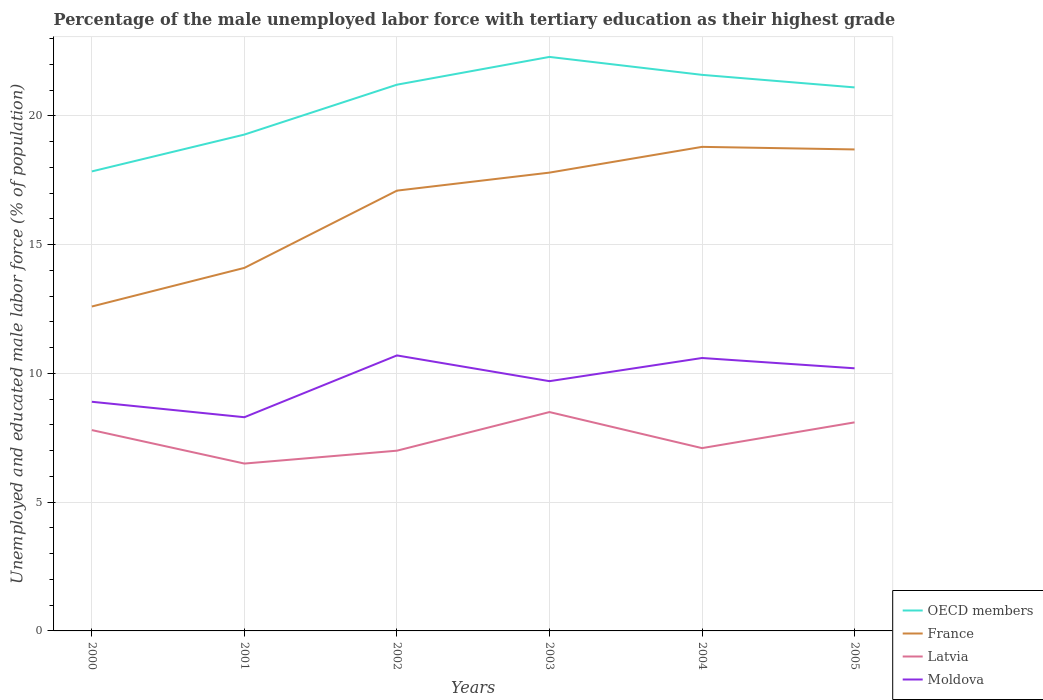How many different coloured lines are there?
Offer a terse response. 4. Does the line corresponding to France intersect with the line corresponding to Moldova?
Provide a succinct answer. No. Across all years, what is the maximum percentage of the unemployed male labor force with tertiary education in France?
Your answer should be very brief. 12.6. In which year was the percentage of the unemployed male labor force with tertiary education in France maximum?
Offer a very short reply. 2000. What is the total percentage of the unemployed male labor force with tertiary education in Moldova in the graph?
Provide a short and direct response. 0.4. What is the difference between the highest and the second highest percentage of the unemployed male labor force with tertiary education in Moldova?
Make the answer very short. 2.4. Is the percentage of the unemployed male labor force with tertiary education in Latvia strictly greater than the percentage of the unemployed male labor force with tertiary education in OECD members over the years?
Ensure brevity in your answer.  Yes. How many years are there in the graph?
Ensure brevity in your answer.  6. What is the difference between two consecutive major ticks on the Y-axis?
Your answer should be compact. 5. Does the graph contain grids?
Make the answer very short. Yes. What is the title of the graph?
Keep it short and to the point. Percentage of the male unemployed labor force with tertiary education as their highest grade. What is the label or title of the X-axis?
Your response must be concise. Years. What is the label or title of the Y-axis?
Your response must be concise. Unemployed and educated male labor force (% of population). What is the Unemployed and educated male labor force (% of population) of OECD members in 2000?
Offer a very short reply. 17.85. What is the Unemployed and educated male labor force (% of population) in France in 2000?
Give a very brief answer. 12.6. What is the Unemployed and educated male labor force (% of population) of Latvia in 2000?
Provide a succinct answer. 7.8. What is the Unemployed and educated male labor force (% of population) of Moldova in 2000?
Ensure brevity in your answer.  8.9. What is the Unemployed and educated male labor force (% of population) of OECD members in 2001?
Provide a short and direct response. 19.28. What is the Unemployed and educated male labor force (% of population) of France in 2001?
Give a very brief answer. 14.1. What is the Unemployed and educated male labor force (% of population) in Latvia in 2001?
Offer a very short reply. 6.5. What is the Unemployed and educated male labor force (% of population) of Moldova in 2001?
Your answer should be very brief. 8.3. What is the Unemployed and educated male labor force (% of population) in OECD members in 2002?
Offer a very short reply. 21.21. What is the Unemployed and educated male labor force (% of population) in France in 2002?
Your response must be concise. 17.1. What is the Unemployed and educated male labor force (% of population) of Moldova in 2002?
Give a very brief answer. 10.7. What is the Unemployed and educated male labor force (% of population) in OECD members in 2003?
Your answer should be compact. 22.29. What is the Unemployed and educated male labor force (% of population) in France in 2003?
Provide a succinct answer. 17.8. What is the Unemployed and educated male labor force (% of population) of Moldova in 2003?
Give a very brief answer. 9.7. What is the Unemployed and educated male labor force (% of population) of OECD members in 2004?
Provide a succinct answer. 21.6. What is the Unemployed and educated male labor force (% of population) in France in 2004?
Ensure brevity in your answer.  18.8. What is the Unemployed and educated male labor force (% of population) of Latvia in 2004?
Give a very brief answer. 7.1. What is the Unemployed and educated male labor force (% of population) of Moldova in 2004?
Offer a terse response. 10.6. What is the Unemployed and educated male labor force (% of population) of OECD members in 2005?
Ensure brevity in your answer.  21.11. What is the Unemployed and educated male labor force (% of population) in France in 2005?
Provide a succinct answer. 18.7. What is the Unemployed and educated male labor force (% of population) of Latvia in 2005?
Keep it short and to the point. 8.1. What is the Unemployed and educated male labor force (% of population) in Moldova in 2005?
Your answer should be compact. 10.2. Across all years, what is the maximum Unemployed and educated male labor force (% of population) in OECD members?
Keep it short and to the point. 22.29. Across all years, what is the maximum Unemployed and educated male labor force (% of population) in France?
Provide a succinct answer. 18.8. Across all years, what is the maximum Unemployed and educated male labor force (% of population) in Latvia?
Provide a short and direct response. 8.5. Across all years, what is the maximum Unemployed and educated male labor force (% of population) of Moldova?
Your answer should be very brief. 10.7. Across all years, what is the minimum Unemployed and educated male labor force (% of population) in OECD members?
Offer a terse response. 17.85. Across all years, what is the minimum Unemployed and educated male labor force (% of population) of France?
Provide a succinct answer. 12.6. Across all years, what is the minimum Unemployed and educated male labor force (% of population) of Moldova?
Provide a short and direct response. 8.3. What is the total Unemployed and educated male labor force (% of population) of OECD members in the graph?
Provide a short and direct response. 123.34. What is the total Unemployed and educated male labor force (% of population) in France in the graph?
Your answer should be very brief. 99.1. What is the total Unemployed and educated male labor force (% of population) in Moldova in the graph?
Your answer should be very brief. 58.4. What is the difference between the Unemployed and educated male labor force (% of population) in OECD members in 2000 and that in 2001?
Offer a very short reply. -1.43. What is the difference between the Unemployed and educated male labor force (% of population) of OECD members in 2000 and that in 2002?
Your answer should be compact. -3.37. What is the difference between the Unemployed and educated male labor force (% of population) in Latvia in 2000 and that in 2002?
Your answer should be very brief. 0.8. What is the difference between the Unemployed and educated male labor force (% of population) of OECD members in 2000 and that in 2003?
Give a very brief answer. -4.45. What is the difference between the Unemployed and educated male labor force (% of population) of France in 2000 and that in 2003?
Offer a very short reply. -5.2. What is the difference between the Unemployed and educated male labor force (% of population) in Latvia in 2000 and that in 2003?
Keep it short and to the point. -0.7. What is the difference between the Unemployed and educated male labor force (% of population) in Moldova in 2000 and that in 2003?
Your answer should be compact. -0.8. What is the difference between the Unemployed and educated male labor force (% of population) of OECD members in 2000 and that in 2004?
Provide a succinct answer. -3.75. What is the difference between the Unemployed and educated male labor force (% of population) in France in 2000 and that in 2004?
Provide a succinct answer. -6.2. What is the difference between the Unemployed and educated male labor force (% of population) in Latvia in 2000 and that in 2004?
Your answer should be very brief. 0.7. What is the difference between the Unemployed and educated male labor force (% of population) of Moldova in 2000 and that in 2004?
Offer a terse response. -1.7. What is the difference between the Unemployed and educated male labor force (% of population) in OECD members in 2000 and that in 2005?
Offer a very short reply. -3.26. What is the difference between the Unemployed and educated male labor force (% of population) of France in 2000 and that in 2005?
Provide a succinct answer. -6.1. What is the difference between the Unemployed and educated male labor force (% of population) of OECD members in 2001 and that in 2002?
Ensure brevity in your answer.  -1.94. What is the difference between the Unemployed and educated male labor force (% of population) in France in 2001 and that in 2002?
Give a very brief answer. -3. What is the difference between the Unemployed and educated male labor force (% of population) in Moldova in 2001 and that in 2002?
Give a very brief answer. -2.4. What is the difference between the Unemployed and educated male labor force (% of population) of OECD members in 2001 and that in 2003?
Offer a very short reply. -3.02. What is the difference between the Unemployed and educated male labor force (% of population) in France in 2001 and that in 2003?
Provide a short and direct response. -3.7. What is the difference between the Unemployed and educated male labor force (% of population) of Latvia in 2001 and that in 2003?
Offer a very short reply. -2. What is the difference between the Unemployed and educated male labor force (% of population) of OECD members in 2001 and that in 2004?
Your response must be concise. -2.32. What is the difference between the Unemployed and educated male labor force (% of population) in OECD members in 2001 and that in 2005?
Provide a succinct answer. -1.83. What is the difference between the Unemployed and educated male labor force (% of population) in OECD members in 2002 and that in 2003?
Provide a short and direct response. -1.08. What is the difference between the Unemployed and educated male labor force (% of population) of France in 2002 and that in 2003?
Give a very brief answer. -0.7. What is the difference between the Unemployed and educated male labor force (% of population) in Latvia in 2002 and that in 2003?
Your answer should be compact. -1.5. What is the difference between the Unemployed and educated male labor force (% of population) in OECD members in 2002 and that in 2004?
Keep it short and to the point. -0.38. What is the difference between the Unemployed and educated male labor force (% of population) of France in 2002 and that in 2004?
Make the answer very short. -1.7. What is the difference between the Unemployed and educated male labor force (% of population) in Latvia in 2002 and that in 2004?
Offer a very short reply. -0.1. What is the difference between the Unemployed and educated male labor force (% of population) of Moldova in 2002 and that in 2004?
Offer a terse response. 0.1. What is the difference between the Unemployed and educated male labor force (% of population) in OECD members in 2002 and that in 2005?
Offer a very short reply. 0.11. What is the difference between the Unemployed and educated male labor force (% of population) in France in 2002 and that in 2005?
Give a very brief answer. -1.6. What is the difference between the Unemployed and educated male labor force (% of population) of Latvia in 2002 and that in 2005?
Offer a terse response. -1.1. What is the difference between the Unemployed and educated male labor force (% of population) of OECD members in 2003 and that in 2004?
Keep it short and to the point. 0.7. What is the difference between the Unemployed and educated male labor force (% of population) of Moldova in 2003 and that in 2004?
Your answer should be very brief. -0.9. What is the difference between the Unemployed and educated male labor force (% of population) of OECD members in 2003 and that in 2005?
Your answer should be compact. 1.18. What is the difference between the Unemployed and educated male labor force (% of population) in France in 2003 and that in 2005?
Your response must be concise. -0.9. What is the difference between the Unemployed and educated male labor force (% of population) in Latvia in 2003 and that in 2005?
Give a very brief answer. 0.4. What is the difference between the Unemployed and educated male labor force (% of population) in OECD members in 2004 and that in 2005?
Offer a terse response. 0.49. What is the difference between the Unemployed and educated male labor force (% of population) of France in 2004 and that in 2005?
Offer a very short reply. 0.1. What is the difference between the Unemployed and educated male labor force (% of population) in Latvia in 2004 and that in 2005?
Keep it short and to the point. -1. What is the difference between the Unemployed and educated male labor force (% of population) in Moldova in 2004 and that in 2005?
Provide a succinct answer. 0.4. What is the difference between the Unemployed and educated male labor force (% of population) of OECD members in 2000 and the Unemployed and educated male labor force (% of population) of France in 2001?
Your response must be concise. 3.75. What is the difference between the Unemployed and educated male labor force (% of population) of OECD members in 2000 and the Unemployed and educated male labor force (% of population) of Latvia in 2001?
Provide a succinct answer. 11.35. What is the difference between the Unemployed and educated male labor force (% of population) in OECD members in 2000 and the Unemployed and educated male labor force (% of population) in Moldova in 2001?
Provide a succinct answer. 9.55. What is the difference between the Unemployed and educated male labor force (% of population) in France in 2000 and the Unemployed and educated male labor force (% of population) in Latvia in 2001?
Offer a terse response. 6.1. What is the difference between the Unemployed and educated male labor force (% of population) of France in 2000 and the Unemployed and educated male labor force (% of population) of Moldova in 2001?
Provide a succinct answer. 4.3. What is the difference between the Unemployed and educated male labor force (% of population) of OECD members in 2000 and the Unemployed and educated male labor force (% of population) of France in 2002?
Your response must be concise. 0.75. What is the difference between the Unemployed and educated male labor force (% of population) of OECD members in 2000 and the Unemployed and educated male labor force (% of population) of Latvia in 2002?
Your response must be concise. 10.85. What is the difference between the Unemployed and educated male labor force (% of population) in OECD members in 2000 and the Unemployed and educated male labor force (% of population) in Moldova in 2002?
Offer a terse response. 7.15. What is the difference between the Unemployed and educated male labor force (% of population) in OECD members in 2000 and the Unemployed and educated male labor force (% of population) in France in 2003?
Give a very brief answer. 0.05. What is the difference between the Unemployed and educated male labor force (% of population) of OECD members in 2000 and the Unemployed and educated male labor force (% of population) of Latvia in 2003?
Make the answer very short. 9.35. What is the difference between the Unemployed and educated male labor force (% of population) of OECD members in 2000 and the Unemployed and educated male labor force (% of population) of Moldova in 2003?
Your answer should be very brief. 8.15. What is the difference between the Unemployed and educated male labor force (% of population) in France in 2000 and the Unemployed and educated male labor force (% of population) in Latvia in 2003?
Give a very brief answer. 4.1. What is the difference between the Unemployed and educated male labor force (% of population) of OECD members in 2000 and the Unemployed and educated male labor force (% of population) of France in 2004?
Your answer should be very brief. -0.95. What is the difference between the Unemployed and educated male labor force (% of population) of OECD members in 2000 and the Unemployed and educated male labor force (% of population) of Latvia in 2004?
Offer a terse response. 10.75. What is the difference between the Unemployed and educated male labor force (% of population) of OECD members in 2000 and the Unemployed and educated male labor force (% of population) of Moldova in 2004?
Your answer should be very brief. 7.25. What is the difference between the Unemployed and educated male labor force (% of population) in France in 2000 and the Unemployed and educated male labor force (% of population) in Moldova in 2004?
Provide a short and direct response. 2. What is the difference between the Unemployed and educated male labor force (% of population) of Latvia in 2000 and the Unemployed and educated male labor force (% of population) of Moldova in 2004?
Provide a short and direct response. -2.8. What is the difference between the Unemployed and educated male labor force (% of population) of OECD members in 2000 and the Unemployed and educated male labor force (% of population) of France in 2005?
Offer a very short reply. -0.85. What is the difference between the Unemployed and educated male labor force (% of population) in OECD members in 2000 and the Unemployed and educated male labor force (% of population) in Latvia in 2005?
Your answer should be compact. 9.75. What is the difference between the Unemployed and educated male labor force (% of population) of OECD members in 2000 and the Unemployed and educated male labor force (% of population) of Moldova in 2005?
Your answer should be compact. 7.65. What is the difference between the Unemployed and educated male labor force (% of population) in France in 2000 and the Unemployed and educated male labor force (% of population) in Latvia in 2005?
Your answer should be very brief. 4.5. What is the difference between the Unemployed and educated male labor force (% of population) in France in 2000 and the Unemployed and educated male labor force (% of population) in Moldova in 2005?
Keep it short and to the point. 2.4. What is the difference between the Unemployed and educated male labor force (% of population) of Latvia in 2000 and the Unemployed and educated male labor force (% of population) of Moldova in 2005?
Offer a terse response. -2.4. What is the difference between the Unemployed and educated male labor force (% of population) in OECD members in 2001 and the Unemployed and educated male labor force (% of population) in France in 2002?
Your response must be concise. 2.18. What is the difference between the Unemployed and educated male labor force (% of population) of OECD members in 2001 and the Unemployed and educated male labor force (% of population) of Latvia in 2002?
Provide a succinct answer. 12.28. What is the difference between the Unemployed and educated male labor force (% of population) in OECD members in 2001 and the Unemployed and educated male labor force (% of population) in Moldova in 2002?
Ensure brevity in your answer.  8.58. What is the difference between the Unemployed and educated male labor force (% of population) of France in 2001 and the Unemployed and educated male labor force (% of population) of Latvia in 2002?
Your answer should be very brief. 7.1. What is the difference between the Unemployed and educated male labor force (% of population) of France in 2001 and the Unemployed and educated male labor force (% of population) of Moldova in 2002?
Make the answer very short. 3.4. What is the difference between the Unemployed and educated male labor force (% of population) in OECD members in 2001 and the Unemployed and educated male labor force (% of population) in France in 2003?
Offer a very short reply. 1.48. What is the difference between the Unemployed and educated male labor force (% of population) in OECD members in 2001 and the Unemployed and educated male labor force (% of population) in Latvia in 2003?
Offer a very short reply. 10.78. What is the difference between the Unemployed and educated male labor force (% of population) of OECD members in 2001 and the Unemployed and educated male labor force (% of population) of Moldova in 2003?
Give a very brief answer. 9.58. What is the difference between the Unemployed and educated male labor force (% of population) of OECD members in 2001 and the Unemployed and educated male labor force (% of population) of France in 2004?
Keep it short and to the point. 0.48. What is the difference between the Unemployed and educated male labor force (% of population) of OECD members in 2001 and the Unemployed and educated male labor force (% of population) of Latvia in 2004?
Give a very brief answer. 12.18. What is the difference between the Unemployed and educated male labor force (% of population) of OECD members in 2001 and the Unemployed and educated male labor force (% of population) of Moldova in 2004?
Provide a short and direct response. 8.68. What is the difference between the Unemployed and educated male labor force (% of population) in France in 2001 and the Unemployed and educated male labor force (% of population) in Latvia in 2004?
Your answer should be very brief. 7. What is the difference between the Unemployed and educated male labor force (% of population) of France in 2001 and the Unemployed and educated male labor force (% of population) of Moldova in 2004?
Your response must be concise. 3.5. What is the difference between the Unemployed and educated male labor force (% of population) in OECD members in 2001 and the Unemployed and educated male labor force (% of population) in France in 2005?
Provide a short and direct response. 0.58. What is the difference between the Unemployed and educated male labor force (% of population) of OECD members in 2001 and the Unemployed and educated male labor force (% of population) of Latvia in 2005?
Your answer should be very brief. 11.18. What is the difference between the Unemployed and educated male labor force (% of population) of OECD members in 2001 and the Unemployed and educated male labor force (% of population) of Moldova in 2005?
Keep it short and to the point. 9.08. What is the difference between the Unemployed and educated male labor force (% of population) of France in 2001 and the Unemployed and educated male labor force (% of population) of Latvia in 2005?
Provide a succinct answer. 6. What is the difference between the Unemployed and educated male labor force (% of population) of OECD members in 2002 and the Unemployed and educated male labor force (% of population) of France in 2003?
Keep it short and to the point. 3.41. What is the difference between the Unemployed and educated male labor force (% of population) of OECD members in 2002 and the Unemployed and educated male labor force (% of population) of Latvia in 2003?
Offer a terse response. 12.71. What is the difference between the Unemployed and educated male labor force (% of population) of OECD members in 2002 and the Unemployed and educated male labor force (% of population) of Moldova in 2003?
Your answer should be very brief. 11.51. What is the difference between the Unemployed and educated male labor force (% of population) of OECD members in 2002 and the Unemployed and educated male labor force (% of population) of France in 2004?
Provide a succinct answer. 2.41. What is the difference between the Unemployed and educated male labor force (% of population) in OECD members in 2002 and the Unemployed and educated male labor force (% of population) in Latvia in 2004?
Provide a succinct answer. 14.11. What is the difference between the Unemployed and educated male labor force (% of population) in OECD members in 2002 and the Unemployed and educated male labor force (% of population) in Moldova in 2004?
Your answer should be compact. 10.61. What is the difference between the Unemployed and educated male labor force (% of population) in France in 2002 and the Unemployed and educated male labor force (% of population) in Moldova in 2004?
Offer a very short reply. 6.5. What is the difference between the Unemployed and educated male labor force (% of population) of OECD members in 2002 and the Unemployed and educated male labor force (% of population) of France in 2005?
Offer a terse response. 2.51. What is the difference between the Unemployed and educated male labor force (% of population) of OECD members in 2002 and the Unemployed and educated male labor force (% of population) of Latvia in 2005?
Make the answer very short. 13.11. What is the difference between the Unemployed and educated male labor force (% of population) of OECD members in 2002 and the Unemployed and educated male labor force (% of population) of Moldova in 2005?
Provide a succinct answer. 11.01. What is the difference between the Unemployed and educated male labor force (% of population) of France in 2002 and the Unemployed and educated male labor force (% of population) of Latvia in 2005?
Keep it short and to the point. 9. What is the difference between the Unemployed and educated male labor force (% of population) of OECD members in 2003 and the Unemployed and educated male labor force (% of population) of France in 2004?
Offer a terse response. 3.49. What is the difference between the Unemployed and educated male labor force (% of population) of OECD members in 2003 and the Unemployed and educated male labor force (% of population) of Latvia in 2004?
Give a very brief answer. 15.19. What is the difference between the Unemployed and educated male labor force (% of population) in OECD members in 2003 and the Unemployed and educated male labor force (% of population) in Moldova in 2004?
Offer a very short reply. 11.69. What is the difference between the Unemployed and educated male labor force (% of population) in OECD members in 2003 and the Unemployed and educated male labor force (% of population) in France in 2005?
Provide a short and direct response. 3.59. What is the difference between the Unemployed and educated male labor force (% of population) of OECD members in 2003 and the Unemployed and educated male labor force (% of population) of Latvia in 2005?
Your answer should be compact. 14.19. What is the difference between the Unemployed and educated male labor force (% of population) of OECD members in 2003 and the Unemployed and educated male labor force (% of population) of Moldova in 2005?
Your response must be concise. 12.09. What is the difference between the Unemployed and educated male labor force (% of population) in France in 2003 and the Unemployed and educated male labor force (% of population) in Moldova in 2005?
Your answer should be very brief. 7.6. What is the difference between the Unemployed and educated male labor force (% of population) of OECD members in 2004 and the Unemployed and educated male labor force (% of population) of France in 2005?
Your response must be concise. 2.9. What is the difference between the Unemployed and educated male labor force (% of population) of OECD members in 2004 and the Unemployed and educated male labor force (% of population) of Latvia in 2005?
Your answer should be compact. 13.5. What is the difference between the Unemployed and educated male labor force (% of population) in OECD members in 2004 and the Unemployed and educated male labor force (% of population) in Moldova in 2005?
Give a very brief answer. 11.4. What is the difference between the Unemployed and educated male labor force (% of population) in Latvia in 2004 and the Unemployed and educated male labor force (% of population) in Moldova in 2005?
Ensure brevity in your answer.  -3.1. What is the average Unemployed and educated male labor force (% of population) of OECD members per year?
Offer a terse response. 20.56. What is the average Unemployed and educated male labor force (% of population) in France per year?
Your response must be concise. 16.52. What is the average Unemployed and educated male labor force (% of population) of Moldova per year?
Offer a very short reply. 9.73. In the year 2000, what is the difference between the Unemployed and educated male labor force (% of population) of OECD members and Unemployed and educated male labor force (% of population) of France?
Ensure brevity in your answer.  5.25. In the year 2000, what is the difference between the Unemployed and educated male labor force (% of population) in OECD members and Unemployed and educated male labor force (% of population) in Latvia?
Keep it short and to the point. 10.05. In the year 2000, what is the difference between the Unemployed and educated male labor force (% of population) of OECD members and Unemployed and educated male labor force (% of population) of Moldova?
Your answer should be compact. 8.95. In the year 2000, what is the difference between the Unemployed and educated male labor force (% of population) in France and Unemployed and educated male labor force (% of population) in Latvia?
Your answer should be very brief. 4.8. In the year 2000, what is the difference between the Unemployed and educated male labor force (% of population) of Latvia and Unemployed and educated male labor force (% of population) of Moldova?
Offer a terse response. -1.1. In the year 2001, what is the difference between the Unemployed and educated male labor force (% of population) of OECD members and Unemployed and educated male labor force (% of population) of France?
Ensure brevity in your answer.  5.18. In the year 2001, what is the difference between the Unemployed and educated male labor force (% of population) in OECD members and Unemployed and educated male labor force (% of population) in Latvia?
Your answer should be compact. 12.78. In the year 2001, what is the difference between the Unemployed and educated male labor force (% of population) of OECD members and Unemployed and educated male labor force (% of population) of Moldova?
Ensure brevity in your answer.  10.98. In the year 2001, what is the difference between the Unemployed and educated male labor force (% of population) in France and Unemployed and educated male labor force (% of population) in Latvia?
Provide a short and direct response. 7.6. In the year 2001, what is the difference between the Unemployed and educated male labor force (% of population) of France and Unemployed and educated male labor force (% of population) of Moldova?
Make the answer very short. 5.8. In the year 2002, what is the difference between the Unemployed and educated male labor force (% of population) of OECD members and Unemployed and educated male labor force (% of population) of France?
Keep it short and to the point. 4.11. In the year 2002, what is the difference between the Unemployed and educated male labor force (% of population) in OECD members and Unemployed and educated male labor force (% of population) in Latvia?
Give a very brief answer. 14.21. In the year 2002, what is the difference between the Unemployed and educated male labor force (% of population) of OECD members and Unemployed and educated male labor force (% of population) of Moldova?
Your answer should be compact. 10.51. In the year 2002, what is the difference between the Unemployed and educated male labor force (% of population) of France and Unemployed and educated male labor force (% of population) of Latvia?
Your response must be concise. 10.1. In the year 2002, what is the difference between the Unemployed and educated male labor force (% of population) of Latvia and Unemployed and educated male labor force (% of population) of Moldova?
Give a very brief answer. -3.7. In the year 2003, what is the difference between the Unemployed and educated male labor force (% of population) of OECD members and Unemployed and educated male labor force (% of population) of France?
Your answer should be compact. 4.49. In the year 2003, what is the difference between the Unemployed and educated male labor force (% of population) in OECD members and Unemployed and educated male labor force (% of population) in Latvia?
Give a very brief answer. 13.79. In the year 2003, what is the difference between the Unemployed and educated male labor force (% of population) of OECD members and Unemployed and educated male labor force (% of population) of Moldova?
Your answer should be very brief. 12.59. In the year 2003, what is the difference between the Unemployed and educated male labor force (% of population) in France and Unemployed and educated male labor force (% of population) in Latvia?
Provide a short and direct response. 9.3. In the year 2004, what is the difference between the Unemployed and educated male labor force (% of population) in OECD members and Unemployed and educated male labor force (% of population) in France?
Provide a short and direct response. 2.8. In the year 2004, what is the difference between the Unemployed and educated male labor force (% of population) of OECD members and Unemployed and educated male labor force (% of population) of Latvia?
Your answer should be very brief. 14.5. In the year 2004, what is the difference between the Unemployed and educated male labor force (% of population) of OECD members and Unemployed and educated male labor force (% of population) of Moldova?
Provide a short and direct response. 11. In the year 2004, what is the difference between the Unemployed and educated male labor force (% of population) of France and Unemployed and educated male labor force (% of population) of Moldova?
Make the answer very short. 8.2. In the year 2005, what is the difference between the Unemployed and educated male labor force (% of population) in OECD members and Unemployed and educated male labor force (% of population) in France?
Ensure brevity in your answer.  2.41. In the year 2005, what is the difference between the Unemployed and educated male labor force (% of population) of OECD members and Unemployed and educated male labor force (% of population) of Latvia?
Ensure brevity in your answer.  13.01. In the year 2005, what is the difference between the Unemployed and educated male labor force (% of population) in OECD members and Unemployed and educated male labor force (% of population) in Moldova?
Your answer should be compact. 10.91. What is the ratio of the Unemployed and educated male labor force (% of population) of OECD members in 2000 to that in 2001?
Keep it short and to the point. 0.93. What is the ratio of the Unemployed and educated male labor force (% of population) in France in 2000 to that in 2001?
Give a very brief answer. 0.89. What is the ratio of the Unemployed and educated male labor force (% of population) of Latvia in 2000 to that in 2001?
Your answer should be very brief. 1.2. What is the ratio of the Unemployed and educated male labor force (% of population) in Moldova in 2000 to that in 2001?
Your answer should be compact. 1.07. What is the ratio of the Unemployed and educated male labor force (% of population) in OECD members in 2000 to that in 2002?
Keep it short and to the point. 0.84. What is the ratio of the Unemployed and educated male labor force (% of population) of France in 2000 to that in 2002?
Your answer should be compact. 0.74. What is the ratio of the Unemployed and educated male labor force (% of population) in Latvia in 2000 to that in 2002?
Keep it short and to the point. 1.11. What is the ratio of the Unemployed and educated male labor force (% of population) of Moldova in 2000 to that in 2002?
Provide a succinct answer. 0.83. What is the ratio of the Unemployed and educated male labor force (% of population) in OECD members in 2000 to that in 2003?
Make the answer very short. 0.8. What is the ratio of the Unemployed and educated male labor force (% of population) of France in 2000 to that in 2003?
Provide a short and direct response. 0.71. What is the ratio of the Unemployed and educated male labor force (% of population) in Latvia in 2000 to that in 2003?
Keep it short and to the point. 0.92. What is the ratio of the Unemployed and educated male labor force (% of population) in Moldova in 2000 to that in 2003?
Provide a short and direct response. 0.92. What is the ratio of the Unemployed and educated male labor force (% of population) of OECD members in 2000 to that in 2004?
Provide a succinct answer. 0.83. What is the ratio of the Unemployed and educated male labor force (% of population) in France in 2000 to that in 2004?
Offer a terse response. 0.67. What is the ratio of the Unemployed and educated male labor force (% of population) of Latvia in 2000 to that in 2004?
Your answer should be compact. 1.1. What is the ratio of the Unemployed and educated male labor force (% of population) in Moldova in 2000 to that in 2004?
Your answer should be compact. 0.84. What is the ratio of the Unemployed and educated male labor force (% of population) in OECD members in 2000 to that in 2005?
Make the answer very short. 0.85. What is the ratio of the Unemployed and educated male labor force (% of population) of France in 2000 to that in 2005?
Provide a succinct answer. 0.67. What is the ratio of the Unemployed and educated male labor force (% of population) in Latvia in 2000 to that in 2005?
Your response must be concise. 0.96. What is the ratio of the Unemployed and educated male labor force (% of population) of Moldova in 2000 to that in 2005?
Offer a very short reply. 0.87. What is the ratio of the Unemployed and educated male labor force (% of population) in OECD members in 2001 to that in 2002?
Give a very brief answer. 0.91. What is the ratio of the Unemployed and educated male labor force (% of population) in France in 2001 to that in 2002?
Your response must be concise. 0.82. What is the ratio of the Unemployed and educated male labor force (% of population) in Latvia in 2001 to that in 2002?
Provide a succinct answer. 0.93. What is the ratio of the Unemployed and educated male labor force (% of population) in Moldova in 2001 to that in 2002?
Provide a short and direct response. 0.78. What is the ratio of the Unemployed and educated male labor force (% of population) of OECD members in 2001 to that in 2003?
Your response must be concise. 0.86. What is the ratio of the Unemployed and educated male labor force (% of population) of France in 2001 to that in 2003?
Your answer should be very brief. 0.79. What is the ratio of the Unemployed and educated male labor force (% of population) of Latvia in 2001 to that in 2003?
Make the answer very short. 0.76. What is the ratio of the Unemployed and educated male labor force (% of population) in Moldova in 2001 to that in 2003?
Make the answer very short. 0.86. What is the ratio of the Unemployed and educated male labor force (% of population) of OECD members in 2001 to that in 2004?
Your response must be concise. 0.89. What is the ratio of the Unemployed and educated male labor force (% of population) of Latvia in 2001 to that in 2004?
Your answer should be very brief. 0.92. What is the ratio of the Unemployed and educated male labor force (% of population) of Moldova in 2001 to that in 2004?
Ensure brevity in your answer.  0.78. What is the ratio of the Unemployed and educated male labor force (% of population) of OECD members in 2001 to that in 2005?
Keep it short and to the point. 0.91. What is the ratio of the Unemployed and educated male labor force (% of population) of France in 2001 to that in 2005?
Offer a very short reply. 0.75. What is the ratio of the Unemployed and educated male labor force (% of population) of Latvia in 2001 to that in 2005?
Offer a very short reply. 0.8. What is the ratio of the Unemployed and educated male labor force (% of population) in Moldova in 2001 to that in 2005?
Offer a very short reply. 0.81. What is the ratio of the Unemployed and educated male labor force (% of population) of OECD members in 2002 to that in 2003?
Your answer should be very brief. 0.95. What is the ratio of the Unemployed and educated male labor force (% of population) in France in 2002 to that in 2003?
Provide a short and direct response. 0.96. What is the ratio of the Unemployed and educated male labor force (% of population) of Latvia in 2002 to that in 2003?
Make the answer very short. 0.82. What is the ratio of the Unemployed and educated male labor force (% of population) in Moldova in 2002 to that in 2003?
Make the answer very short. 1.1. What is the ratio of the Unemployed and educated male labor force (% of population) in OECD members in 2002 to that in 2004?
Provide a short and direct response. 0.98. What is the ratio of the Unemployed and educated male labor force (% of population) in France in 2002 to that in 2004?
Provide a succinct answer. 0.91. What is the ratio of the Unemployed and educated male labor force (% of population) of Latvia in 2002 to that in 2004?
Make the answer very short. 0.99. What is the ratio of the Unemployed and educated male labor force (% of population) of Moldova in 2002 to that in 2004?
Your answer should be compact. 1.01. What is the ratio of the Unemployed and educated male labor force (% of population) in OECD members in 2002 to that in 2005?
Provide a short and direct response. 1. What is the ratio of the Unemployed and educated male labor force (% of population) in France in 2002 to that in 2005?
Give a very brief answer. 0.91. What is the ratio of the Unemployed and educated male labor force (% of population) in Latvia in 2002 to that in 2005?
Your answer should be very brief. 0.86. What is the ratio of the Unemployed and educated male labor force (% of population) in Moldova in 2002 to that in 2005?
Ensure brevity in your answer.  1.05. What is the ratio of the Unemployed and educated male labor force (% of population) in OECD members in 2003 to that in 2004?
Ensure brevity in your answer.  1.03. What is the ratio of the Unemployed and educated male labor force (% of population) in France in 2003 to that in 2004?
Your answer should be very brief. 0.95. What is the ratio of the Unemployed and educated male labor force (% of population) of Latvia in 2003 to that in 2004?
Offer a terse response. 1.2. What is the ratio of the Unemployed and educated male labor force (% of population) of Moldova in 2003 to that in 2004?
Ensure brevity in your answer.  0.92. What is the ratio of the Unemployed and educated male labor force (% of population) in OECD members in 2003 to that in 2005?
Ensure brevity in your answer.  1.06. What is the ratio of the Unemployed and educated male labor force (% of population) of France in 2003 to that in 2005?
Offer a very short reply. 0.95. What is the ratio of the Unemployed and educated male labor force (% of population) of Latvia in 2003 to that in 2005?
Your answer should be very brief. 1.05. What is the ratio of the Unemployed and educated male labor force (% of population) in Moldova in 2003 to that in 2005?
Keep it short and to the point. 0.95. What is the ratio of the Unemployed and educated male labor force (% of population) in OECD members in 2004 to that in 2005?
Your response must be concise. 1.02. What is the ratio of the Unemployed and educated male labor force (% of population) of France in 2004 to that in 2005?
Offer a terse response. 1.01. What is the ratio of the Unemployed and educated male labor force (% of population) in Latvia in 2004 to that in 2005?
Make the answer very short. 0.88. What is the ratio of the Unemployed and educated male labor force (% of population) in Moldova in 2004 to that in 2005?
Offer a terse response. 1.04. What is the difference between the highest and the second highest Unemployed and educated male labor force (% of population) in OECD members?
Provide a short and direct response. 0.7. What is the difference between the highest and the second highest Unemployed and educated male labor force (% of population) of Latvia?
Keep it short and to the point. 0.4. What is the difference between the highest and the lowest Unemployed and educated male labor force (% of population) of OECD members?
Your response must be concise. 4.45. What is the difference between the highest and the lowest Unemployed and educated male labor force (% of population) in France?
Offer a terse response. 6.2. What is the difference between the highest and the lowest Unemployed and educated male labor force (% of population) of Latvia?
Your answer should be compact. 2. 